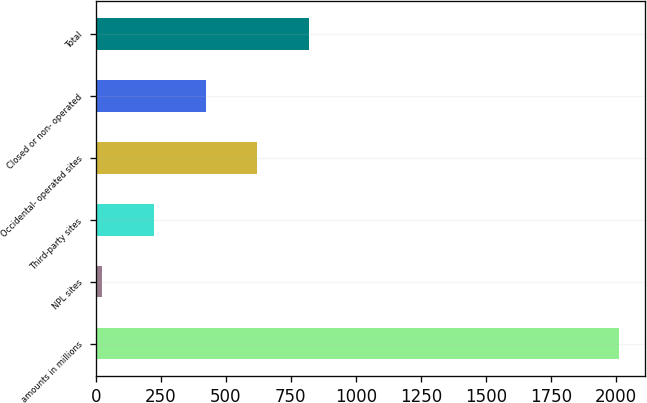Convert chart to OTSL. <chart><loc_0><loc_0><loc_500><loc_500><bar_chart><fcel>amounts in millions<fcel>NPL sites<fcel>Third-party sites<fcel>Occidental- operated sites<fcel>Closed or non- operated<fcel>Total<nl><fcel>2013<fcel>25<fcel>223.8<fcel>621.4<fcel>422.6<fcel>820.2<nl></chart> 